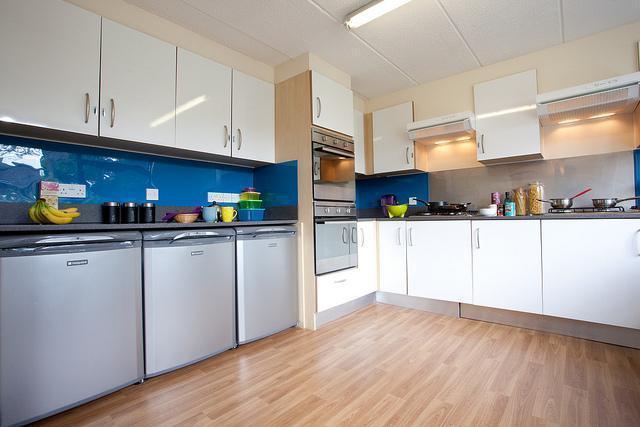How many ovens are there?
Give a very brief answer. 2. 